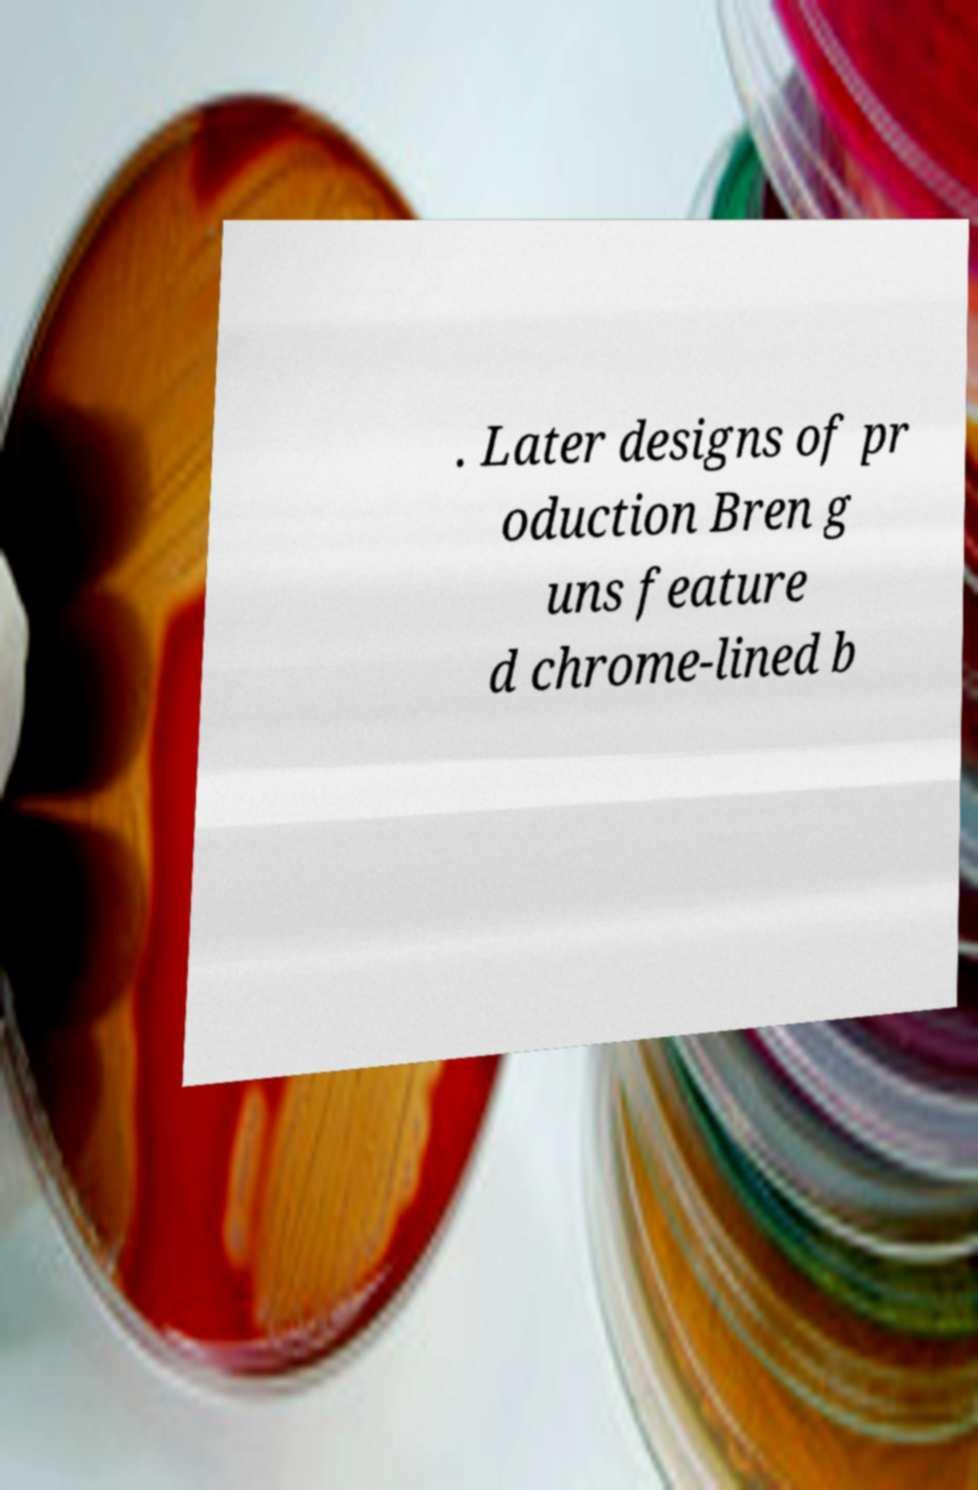Please read and relay the text visible in this image. What does it say? . Later designs of pr oduction Bren g uns feature d chrome-lined b 